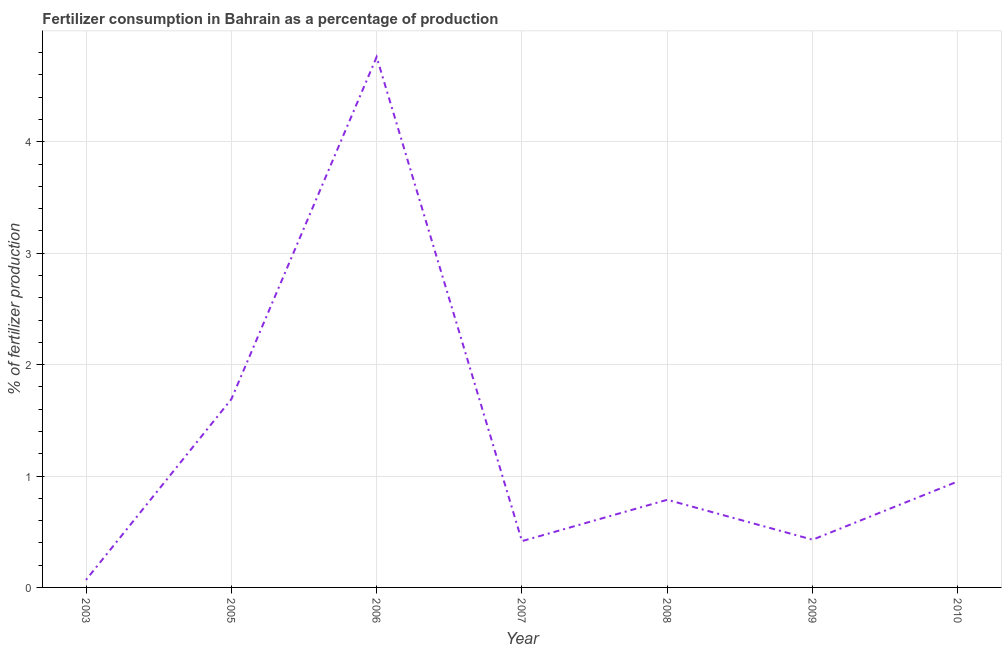What is the amount of fertilizer consumption in 2006?
Provide a short and direct response. 4.76. Across all years, what is the maximum amount of fertilizer consumption?
Offer a terse response. 4.76. Across all years, what is the minimum amount of fertilizer consumption?
Provide a succinct answer. 0.07. In which year was the amount of fertilizer consumption maximum?
Ensure brevity in your answer.  2006. What is the sum of the amount of fertilizer consumption?
Your answer should be compact. 9.1. What is the difference between the amount of fertilizer consumption in 2005 and 2009?
Your answer should be compact. 1.26. What is the average amount of fertilizer consumption per year?
Your answer should be very brief. 1.3. What is the median amount of fertilizer consumption?
Your answer should be very brief. 0.79. In how many years, is the amount of fertilizer consumption greater than 0.6000000000000001 %?
Provide a succinct answer. 4. Do a majority of the years between 2006 and 2007 (inclusive) have amount of fertilizer consumption greater than 4.4 %?
Provide a succinct answer. No. What is the ratio of the amount of fertilizer consumption in 2006 to that in 2008?
Provide a succinct answer. 6.05. Is the amount of fertilizer consumption in 2009 less than that in 2010?
Make the answer very short. Yes. Is the difference between the amount of fertilizer consumption in 2007 and 2008 greater than the difference between any two years?
Offer a terse response. No. What is the difference between the highest and the second highest amount of fertilizer consumption?
Provide a short and direct response. 3.07. What is the difference between the highest and the lowest amount of fertilizer consumption?
Your response must be concise. 4.69. Does the amount of fertilizer consumption monotonically increase over the years?
Your answer should be very brief. No. How many years are there in the graph?
Ensure brevity in your answer.  7. Are the values on the major ticks of Y-axis written in scientific E-notation?
Your response must be concise. No. Does the graph contain any zero values?
Make the answer very short. No. What is the title of the graph?
Make the answer very short. Fertilizer consumption in Bahrain as a percentage of production. What is the label or title of the Y-axis?
Your answer should be compact. % of fertilizer production. What is the % of fertilizer production of 2003?
Ensure brevity in your answer.  0.07. What is the % of fertilizer production in 2005?
Your answer should be very brief. 1.69. What is the % of fertilizer production of 2006?
Your answer should be compact. 4.76. What is the % of fertilizer production in 2007?
Provide a succinct answer. 0.42. What is the % of fertilizer production in 2008?
Your answer should be very brief. 0.79. What is the % of fertilizer production of 2009?
Provide a succinct answer. 0.43. What is the % of fertilizer production of 2010?
Provide a short and direct response. 0.95. What is the difference between the % of fertilizer production in 2003 and 2005?
Keep it short and to the point. -1.62. What is the difference between the % of fertilizer production in 2003 and 2006?
Keep it short and to the point. -4.69. What is the difference between the % of fertilizer production in 2003 and 2007?
Keep it short and to the point. -0.35. What is the difference between the % of fertilizer production in 2003 and 2008?
Your response must be concise. -0.72. What is the difference between the % of fertilizer production in 2003 and 2009?
Your answer should be compact. -0.36. What is the difference between the % of fertilizer production in 2003 and 2010?
Provide a short and direct response. -0.88. What is the difference between the % of fertilizer production in 2005 and 2006?
Offer a very short reply. -3.07. What is the difference between the % of fertilizer production in 2005 and 2007?
Your answer should be compact. 1.27. What is the difference between the % of fertilizer production in 2005 and 2008?
Make the answer very short. 0.9. What is the difference between the % of fertilizer production in 2005 and 2009?
Provide a succinct answer. 1.26. What is the difference between the % of fertilizer production in 2005 and 2010?
Give a very brief answer. 0.74. What is the difference between the % of fertilizer production in 2006 and 2007?
Make the answer very short. 4.35. What is the difference between the % of fertilizer production in 2006 and 2008?
Your response must be concise. 3.98. What is the difference between the % of fertilizer production in 2006 and 2009?
Your response must be concise. 4.33. What is the difference between the % of fertilizer production in 2006 and 2010?
Ensure brevity in your answer.  3.81. What is the difference between the % of fertilizer production in 2007 and 2008?
Your response must be concise. -0.37. What is the difference between the % of fertilizer production in 2007 and 2009?
Provide a succinct answer. -0.01. What is the difference between the % of fertilizer production in 2007 and 2010?
Keep it short and to the point. -0.54. What is the difference between the % of fertilizer production in 2008 and 2009?
Offer a very short reply. 0.36. What is the difference between the % of fertilizer production in 2008 and 2010?
Provide a succinct answer. -0.17. What is the difference between the % of fertilizer production in 2009 and 2010?
Offer a very short reply. -0.52. What is the ratio of the % of fertilizer production in 2003 to that in 2006?
Keep it short and to the point. 0.01. What is the ratio of the % of fertilizer production in 2003 to that in 2007?
Your answer should be very brief. 0.16. What is the ratio of the % of fertilizer production in 2003 to that in 2008?
Offer a terse response. 0.09. What is the ratio of the % of fertilizer production in 2003 to that in 2009?
Your response must be concise. 0.16. What is the ratio of the % of fertilizer production in 2003 to that in 2010?
Make the answer very short. 0.07. What is the ratio of the % of fertilizer production in 2005 to that in 2006?
Offer a terse response. 0.35. What is the ratio of the % of fertilizer production in 2005 to that in 2007?
Your answer should be very brief. 4.07. What is the ratio of the % of fertilizer production in 2005 to that in 2008?
Give a very brief answer. 2.15. What is the ratio of the % of fertilizer production in 2005 to that in 2009?
Provide a short and direct response. 3.94. What is the ratio of the % of fertilizer production in 2005 to that in 2010?
Offer a terse response. 1.77. What is the ratio of the % of fertilizer production in 2006 to that in 2007?
Keep it short and to the point. 11.46. What is the ratio of the % of fertilizer production in 2006 to that in 2008?
Make the answer very short. 6.05. What is the ratio of the % of fertilizer production in 2006 to that in 2009?
Keep it short and to the point. 11.11. What is the ratio of the % of fertilizer production in 2006 to that in 2010?
Your answer should be compact. 5. What is the ratio of the % of fertilizer production in 2007 to that in 2008?
Ensure brevity in your answer.  0.53. What is the ratio of the % of fertilizer production in 2007 to that in 2010?
Give a very brief answer. 0.44. What is the ratio of the % of fertilizer production in 2008 to that in 2009?
Your response must be concise. 1.84. What is the ratio of the % of fertilizer production in 2008 to that in 2010?
Offer a very short reply. 0.83. What is the ratio of the % of fertilizer production in 2009 to that in 2010?
Provide a succinct answer. 0.45. 